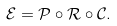Convert formula to latex. <formula><loc_0><loc_0><loc_500><loc_500>\mathcal { E } = \mathcal { P \circ R \circ C } .</formula> 